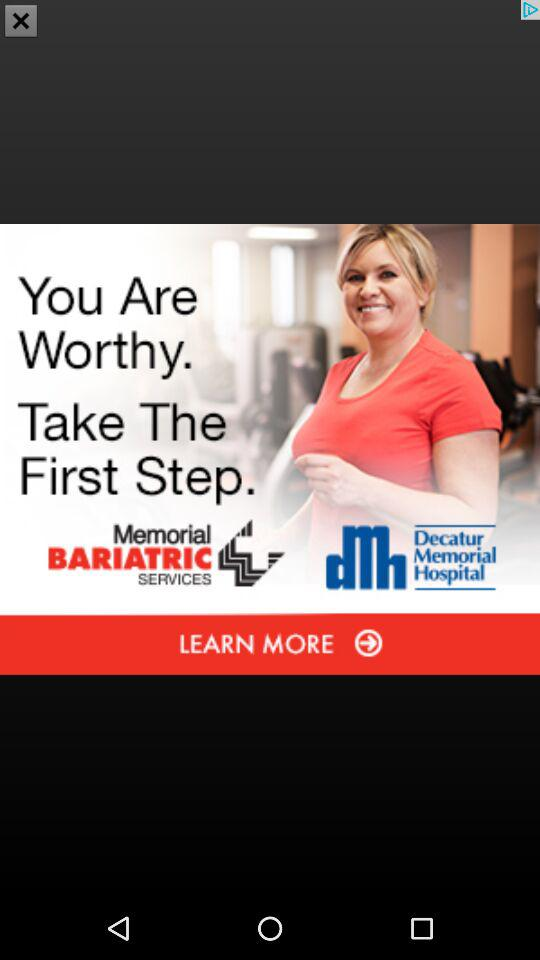How many different types of logos are there on this screen?
Answer the question using a single word or phrase. 2 